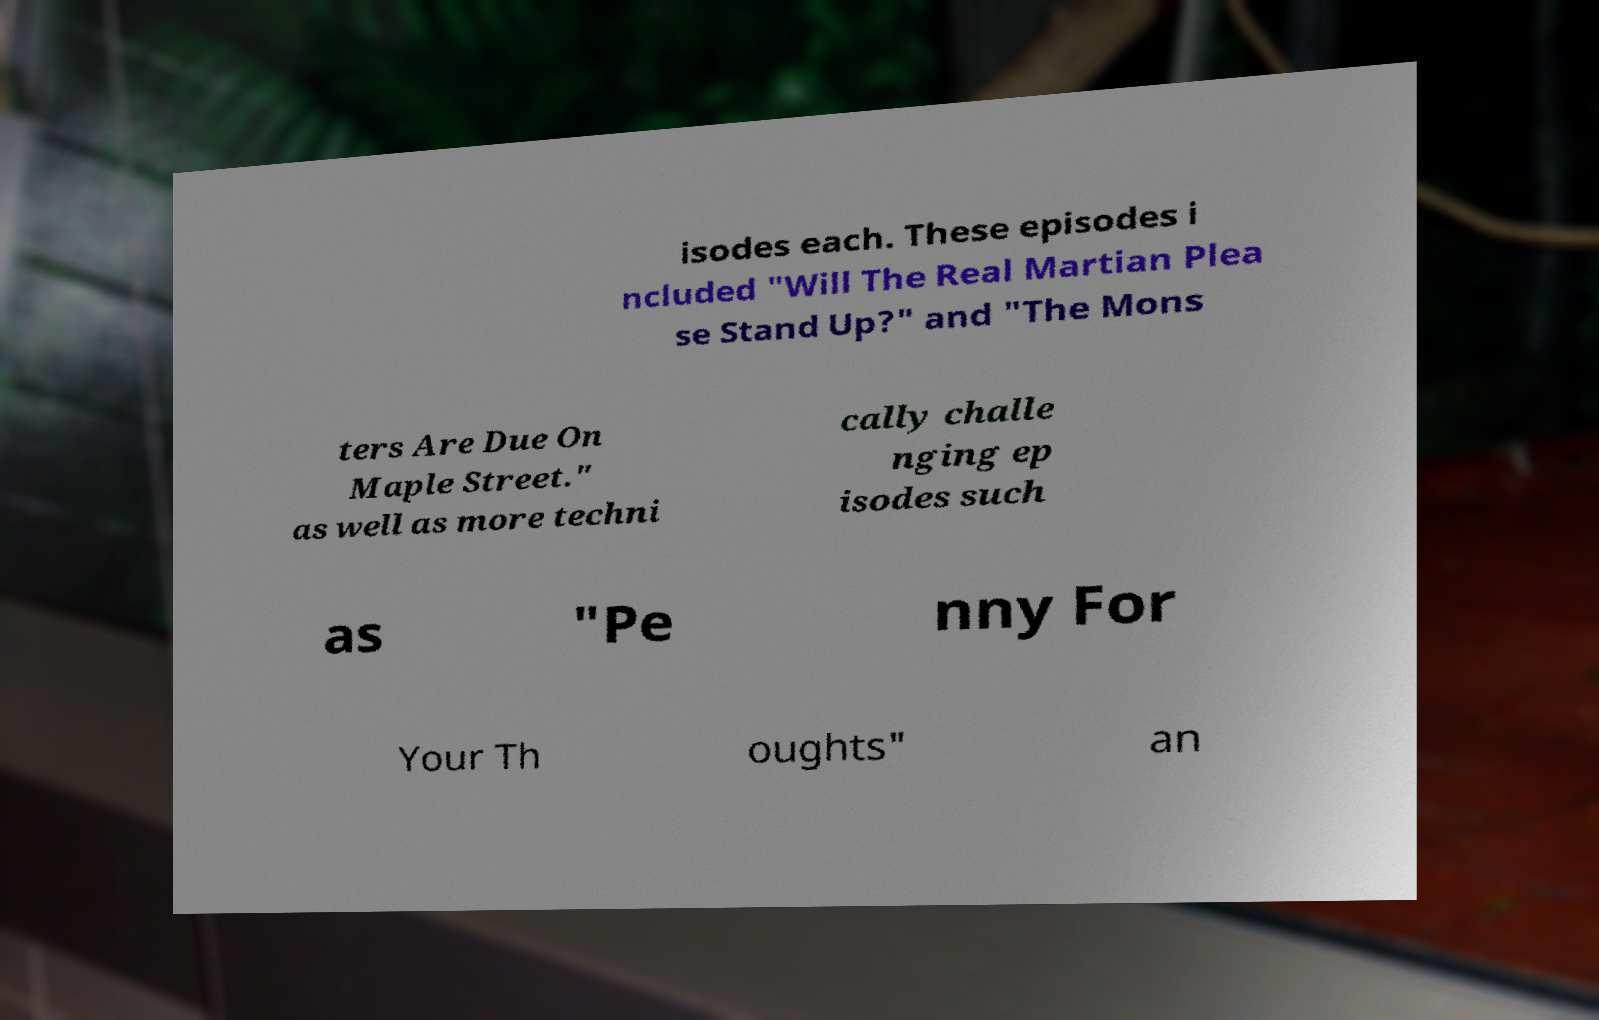What messages or text are displayed in this image? I need them in a readable, typed format. isodes each. These episodes i ncluded "Will The Real Martian Plea se Stand Up?" and "The Mons ters Are Due On Maple Street." as well as more techni cally challe nging ep isodes such as "Pe nny For Your Th oughts" an 